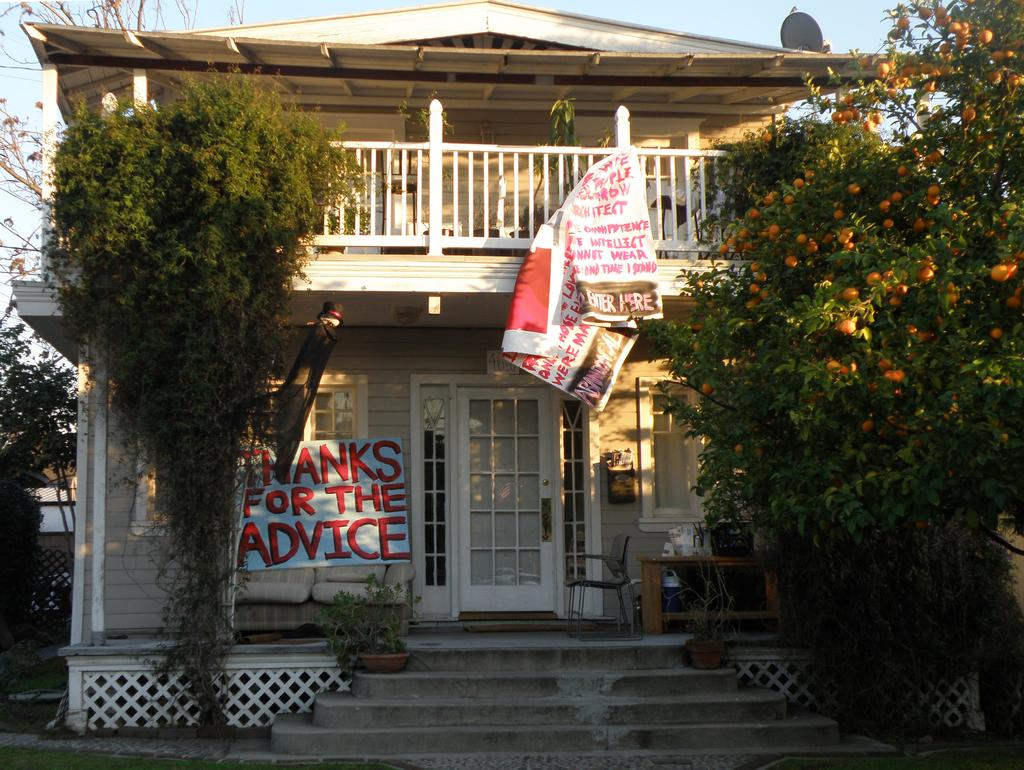<image>
Give a short and clear explanation of the subsequent image. A house with a hanging banner that says Thanks for the Advice. 